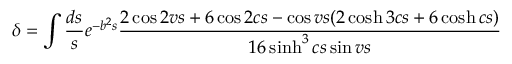<formula> <loc_0><loc_0><loc_500><loc_500>\delta = \int \frac { d s } { s } e ^ { - b ^ { 2 } s } \frac { 2 \cos 2 v s + 6 \cos 2 c s - \cos v s ( 2 \cosh 3 c s + 6 \cosh c s ) } { 1 6 \sinh ^ { 3 } c s \sin v s }</formula> 